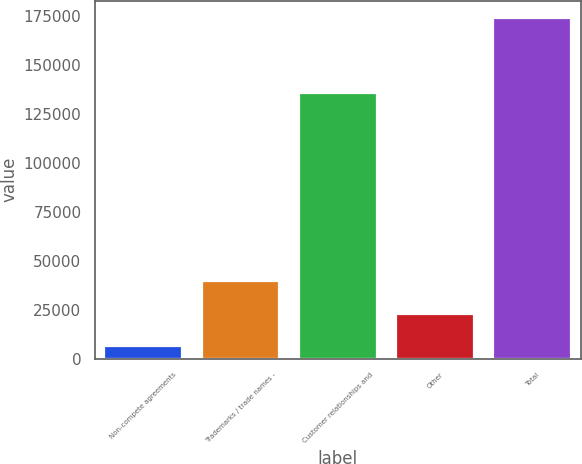<chart> <loc_0><loc_0><loc_500><loc_500><bar_chart><fcel>Non-compete agreements<fcel>Trademarks / trade names -<fcel>Customer relationships and<fcel>Other<fcel>Total<nl><fcel>6186<fcel>39825.4<fcel>135723<fcel>23005.7<fcel>174383<nl></chart> 